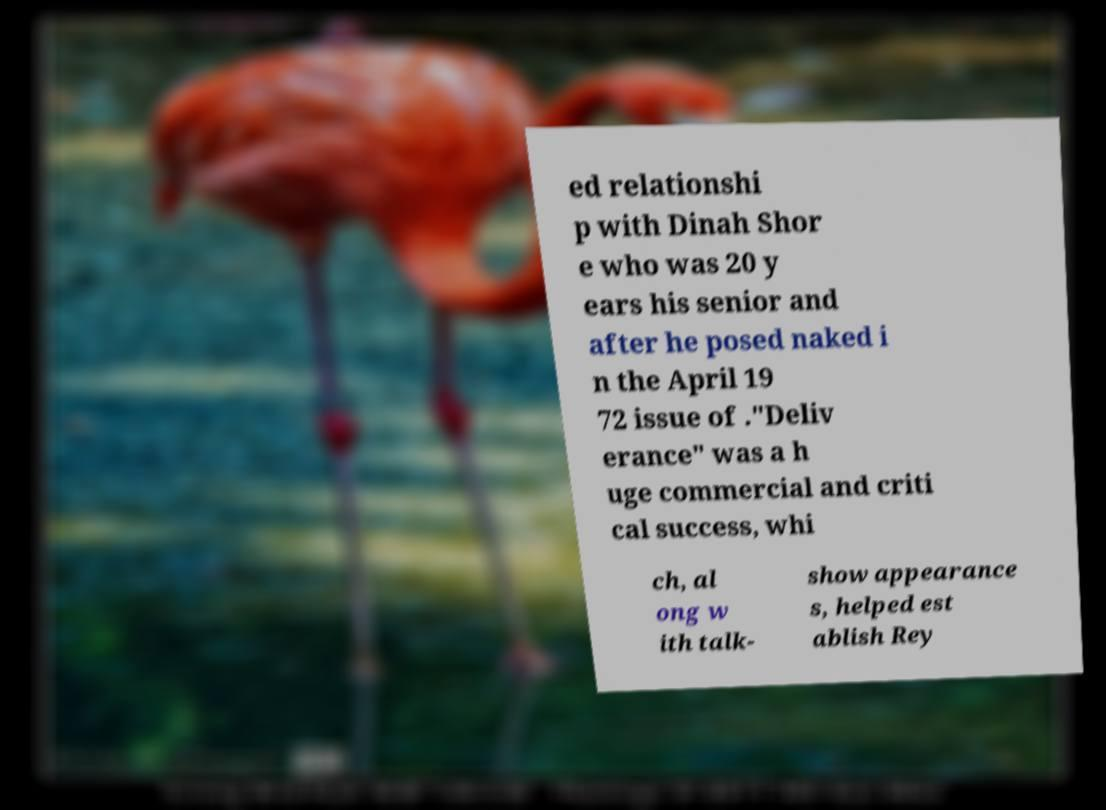What messages or text are displayed in this image? I need them in a readable, typed format. ed relationshi p with Dinah Shor e who was 20 y ears his senior and after he posed naked i n the April 19 72 issue of ."Deliv erance" was a h uge commercial and criti cal success, whi ch, al ong w ith talk- show appearance s, helped est ablish Rey 